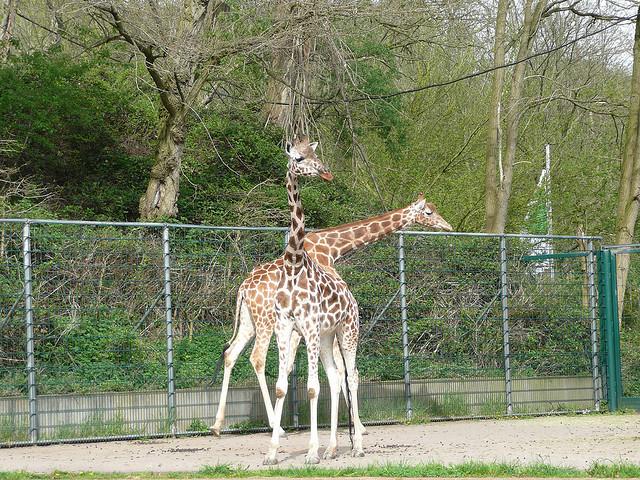How many giraffes are there?
Quick response, please. 2. What are the giraffes behind?
Short answer required. Fence. Is it in Egypt?
Keep it brief. No. Is this a giraffes natural environment?
Short answer required. No. 